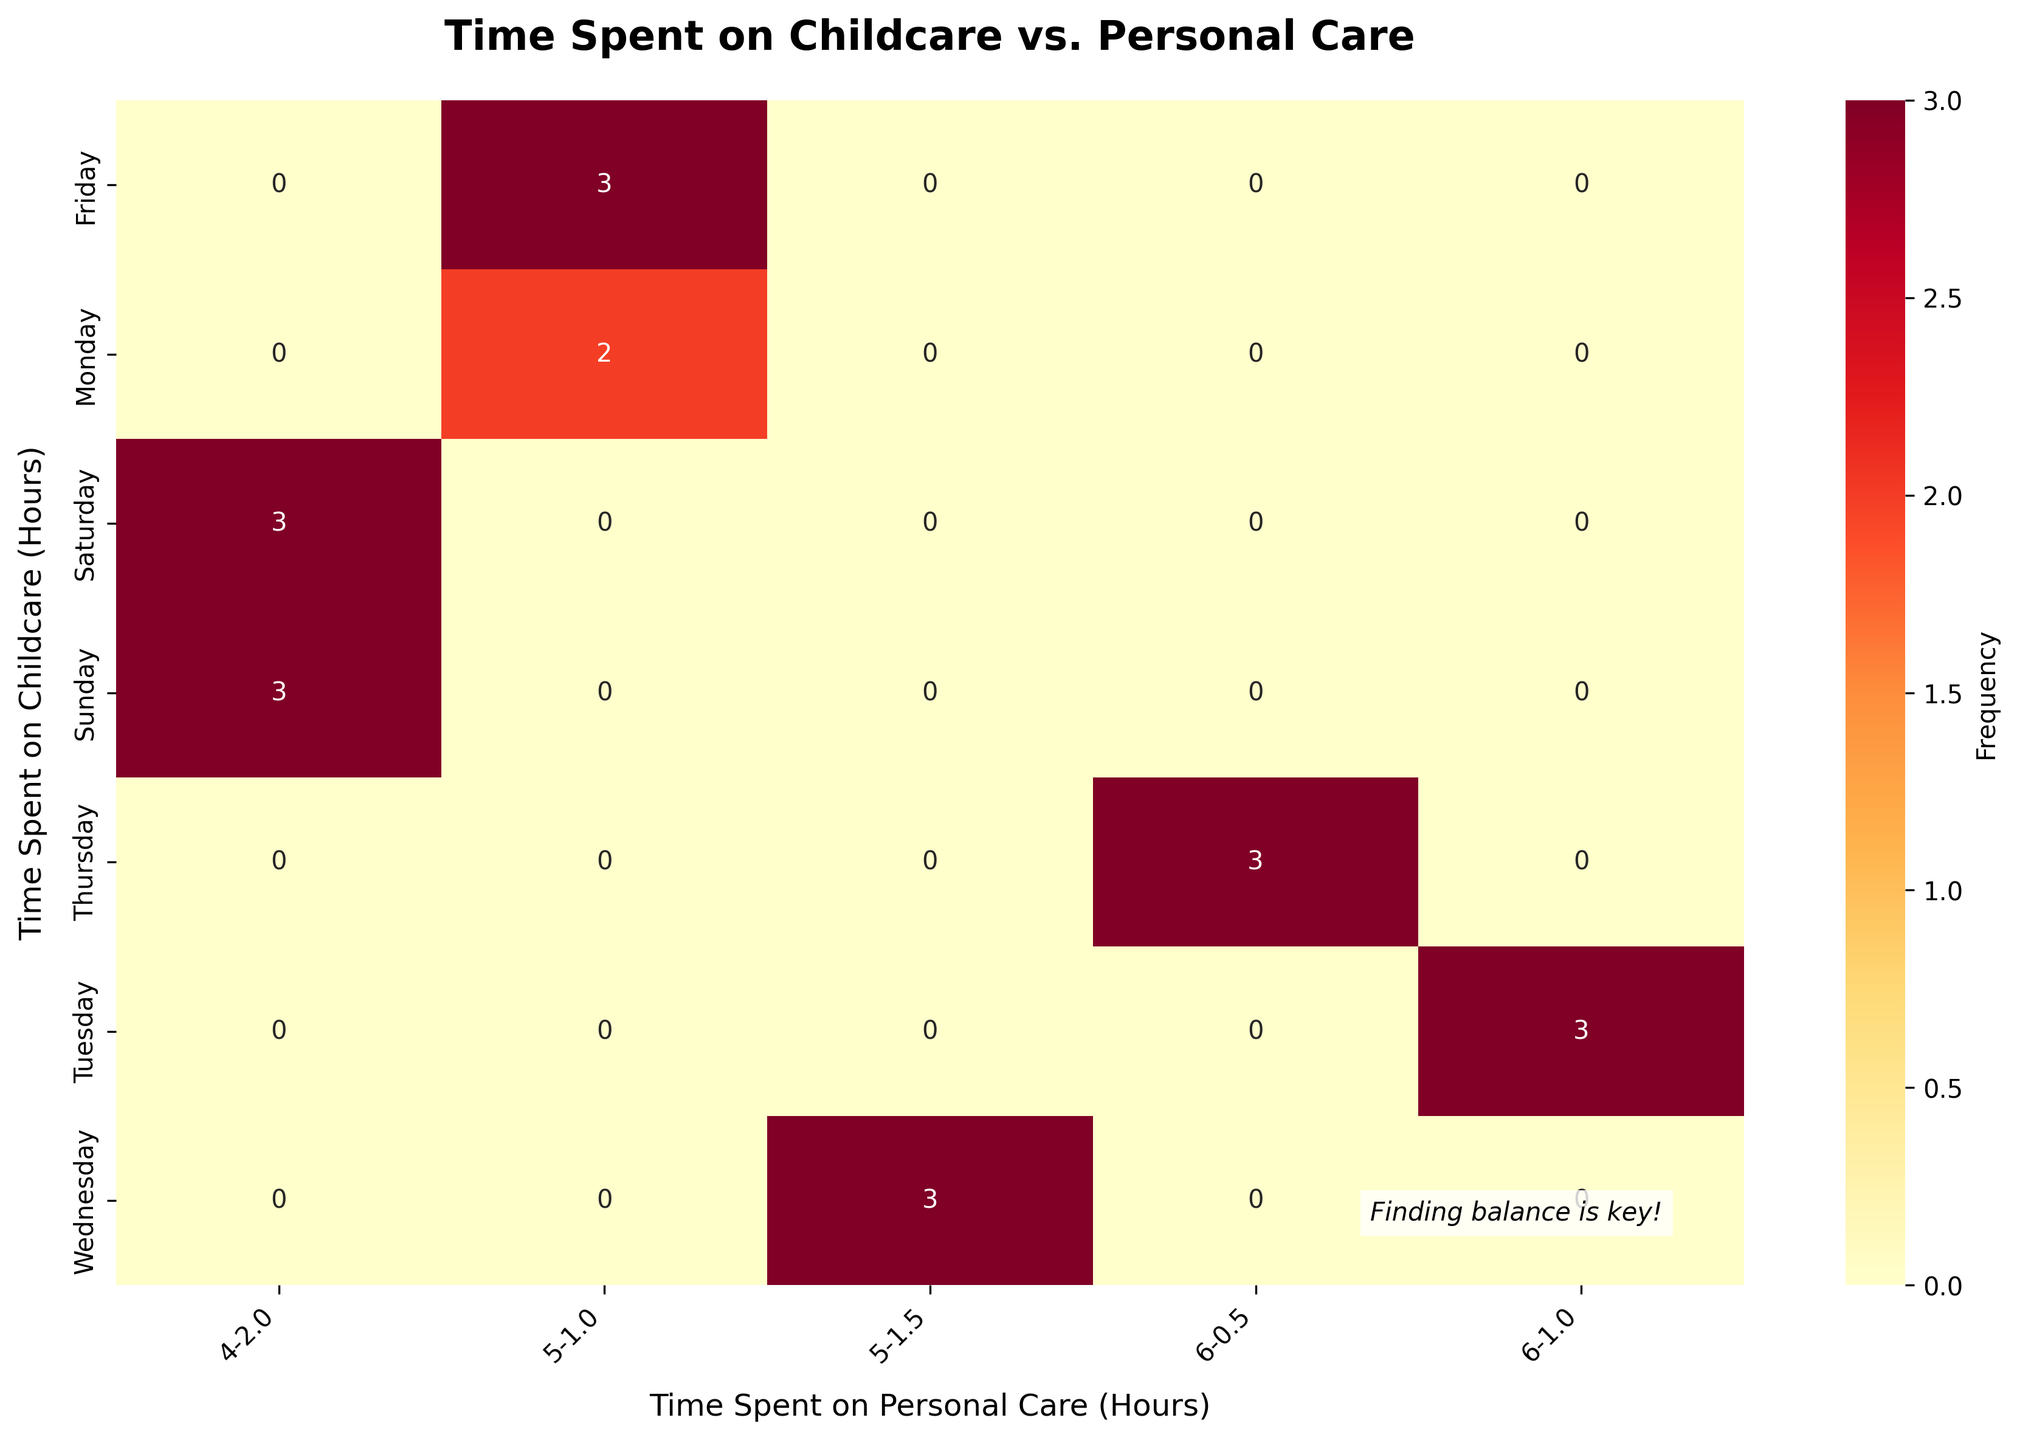What is the title of the figure? The title of the figure is located at the top of the plot and is in bold letters. It reads: "Time Spent on Childcare vs. Personal Care".
Answer: Time Spent on Childcare vs. Personal Care Which day has the highest frequency for 6 hours of childcare and 0.5 hours of personal care? Look at the cell corresponding to 6 hours of childcare and 0.5 hours of personal care, then check the days on the leftmost axis. The day with the highest frequency value in this cell will be the answer.
Answer: Thursday How many total hours are spent on childcare on weekends? Add up the total hours spent on childcare on both Saturday and Sunday. According to the data: 4 hours on Saturday + 4 hours on Sunday = 8 hours
Answer: 8 Which day has the least amount of personal care? Compare the values for personal care hours across different days on the vertical axis and find the minimum value, which is 0.5 hours.
Answer: Thursday What is the sum of the maximum frequency values across all the different childcare-potential care combinations? Identify the highest frequency value in each cell of the heatmap, then sum these values. The highest value in each cell is 1 due to the nature of the data. Summing these values across the heatmap provides the total.
Answer: 18 What day shows a balance between childcare and 2 hours of personal care? Check the column corresponding to 2 hours of personal care and look for the rows with 4 hours of childcare. These rows correspond to the balanced days.
Answer: Saturday and Sunday Are there more hours spent on personal care on weekends compared to weekdays? Calculate the total personal care hours on weekends and weekdays separately: Weekends: 2 hours on Saturday + 2 hours on Sunday = 4 hours. Weekdays: 1+1+1.5+0.5+1 = 5 hours. Compare these totals.
Answer: No How many unique combinations of childcare and personal care times are there? Count the distinct cells in terms of childcare and personal care hours that have non-zero values (which have an annotated number). This gives the number of unique combinations.
Answer: 6 On which day are childcare hours consistently high compared to personal care? Scan through the rows and identify the days where the childcare hours are consistently higher (5 or 6 hours) compared to personal care across the corresponding columns.
Answer: Tuesday and Thursday Is there a day with equal amounts of childcare and personal care hours? Look for matching values in both the childcare and personal care axes. None of the rows and columns have matching hours.
Answer: No 